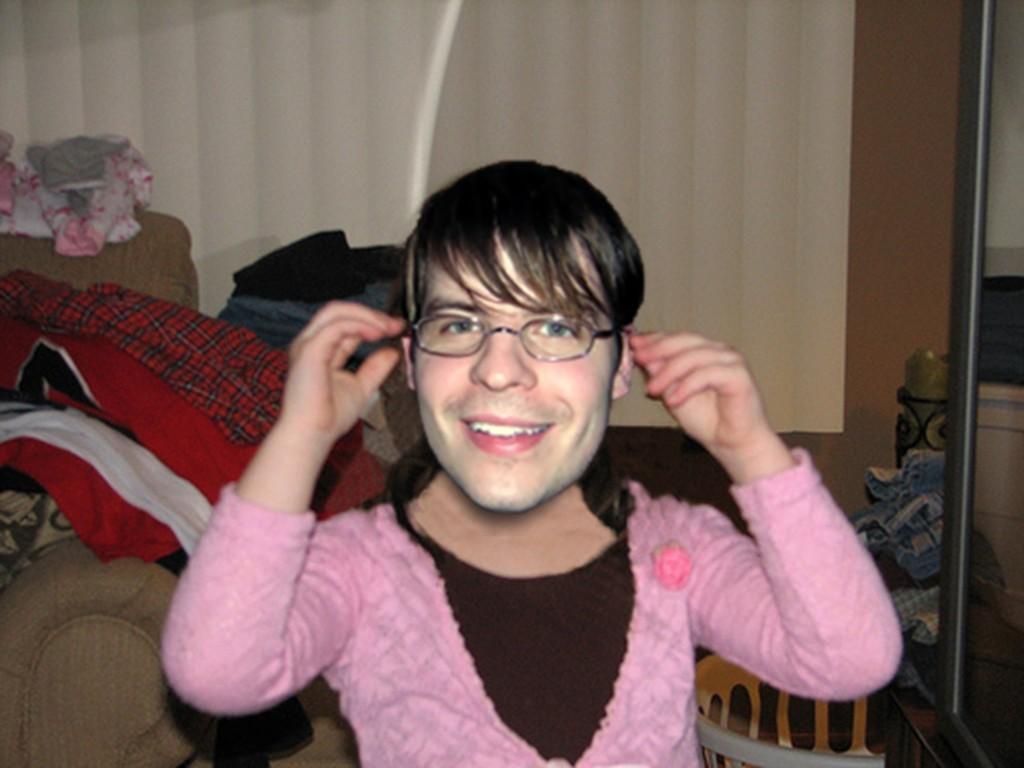Describe this image in one or two sentences. In this image there is a person with a smile on his face, behind the person on the sofa there are clothes, behind the sofa there is a curtain, beside the person there is a mirror, beside the mirror there is an object, in front of the mirror there is a basket. 